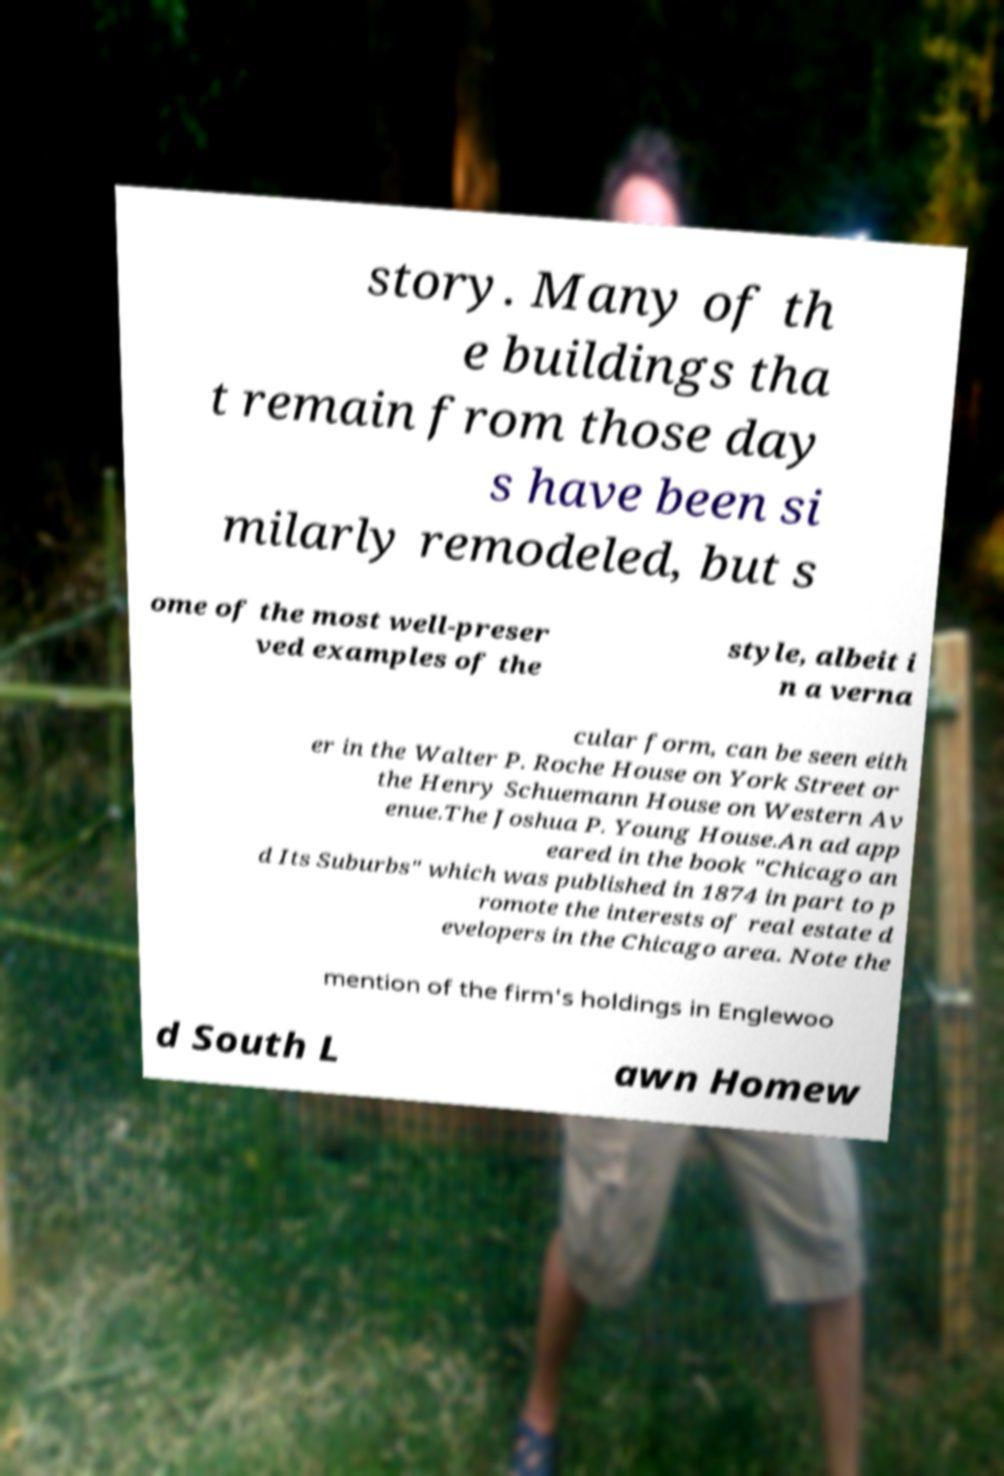Could you extract and type out the text from this image? story. Many of th e buildings tha t remain from those day s have been si milarly remodeled, but s ome of the most well-preser ved examples of the style, albeit i n a verna cular form, can be seen eith er in the Walter P. Roche House on York Street or the Henry Schuemann House on Western Av enue.The Joshua P. Young House.An ad app eared in the book "Chicago an d Its Suburbs" which was published in 1874 in part to p romote the interests of real estate d evelopers in the Chicago area. Note the mention of the firm's holdings in Englewoo d South L awn Homew 